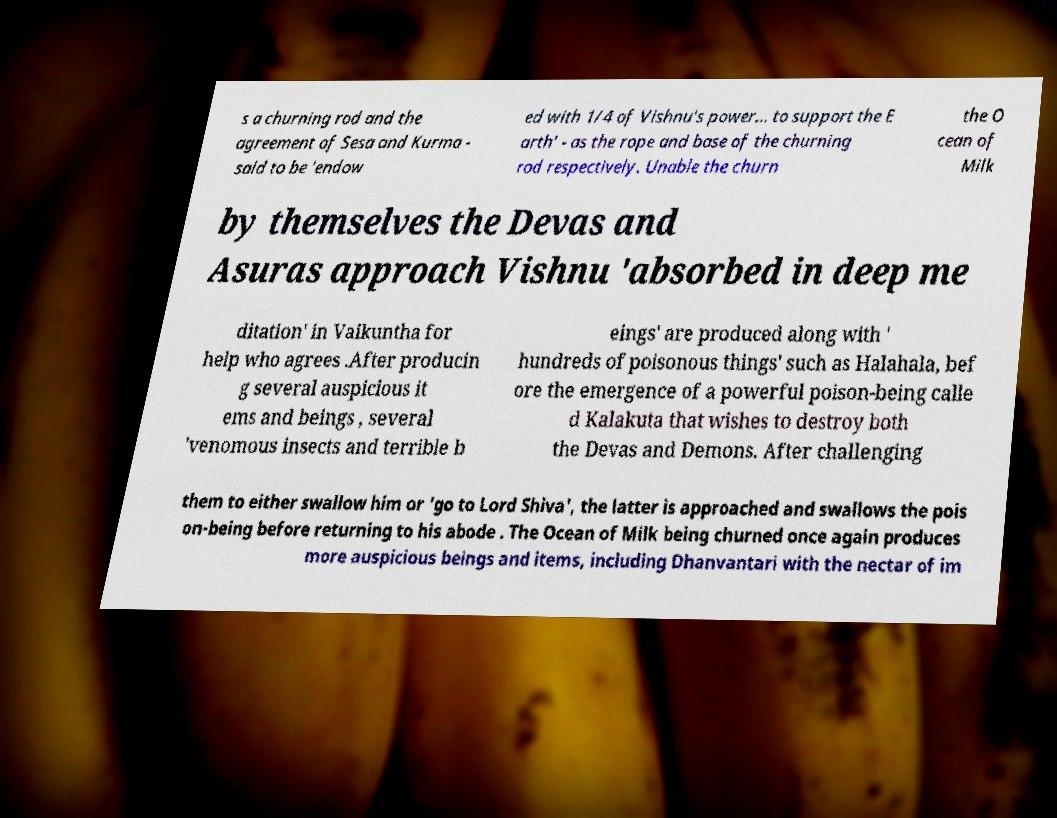For documentation purposes, I need the text within this image transcribed. Could you provide that? s a churning rod and the agreement of Sesa and Kurma - said to be 'endow ed with 1/4 of Vishnu's power... to support the E arth' - as the rope and base of the churning rod respectively. Unable the churn the O cean of Milk by themselves the Devas and Asuras approach Vishnu 'absorbed in deep me ditation' in Vaikuntha for help who agrees .After producin g several auspicious it ems and beings , several 'venomous insects and terrible b eings' are produced along with ' hundreds of poisonous things' such as Halahala, bef ore the emergence of a powerful poison-being calle d Kalakuta that wishes to destroy both the Devas and Demons. After challenging them to either swallow him or 'go to Lord Shiva', the latter is approached and swallows the pois on-being before returning to his abode . The Ocean of Milk being churned once again produces more auspicious beings and items, including Dhanvantari with the nectar of im 